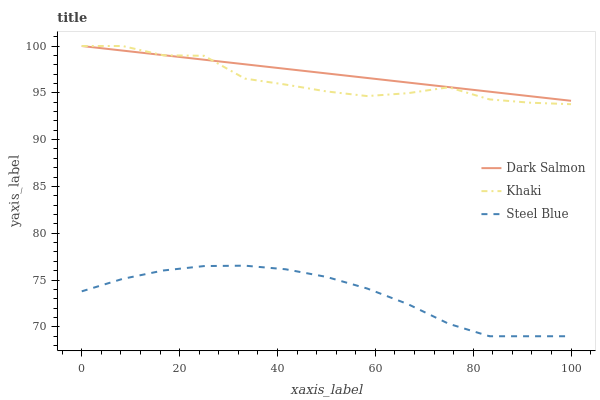Does Steel Blue have the minimum area under the curve?
Answer yes or no. Yes. Does Dark Salmon have the maximum area under the curve?
Answer yes or no. Yes. Does Dark Salmon have the minimum area under the curve?
Answer yes or no. No. Does Steel Blue have the maximum area under the curve?
Answer yes or no. No. Is Dark Salmon the smoothest?
Answer yes or no. Yes. Is Khaki the roughest?
Answer yes or no. Yes. Is Steel Blue the smoothest?
Answer yes or no. No. Is Steel Blue the roughest?
Answer yes or no. No. Does Steel Blue have the lowest value?
Answer yes or no. Yes. Does Dark Salmon have the lowest value?
Answer yes or no. No. Does Dark Salmon have the highest value?
Answer yes or no. Yes. Does Steel Blue have the highest value?
Answer yes or no. No. Is Steel Blue less than Dark Salmon?
Answer yes or no. Yes. Is Khaki greater than Steel Blue?
Answer yes or no. Yes. Does Khaki intersect Dark Salmon?
Answer yes or no. Yes. Is Khaki less than Dark Salmon?
Answer yes or no. No. Is Khaki greater than Dark Salmon?
Answer yes or no. No. Does Steel Blue intersect Dark Salmon?
Answer yes or no. No. 